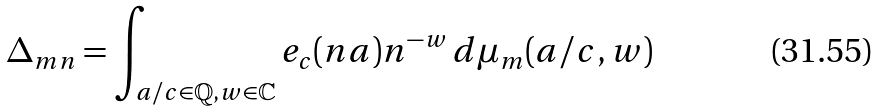Convert formula to latex. <formula><loc_0><loc_0><loc_500><loc_500>\Delta _ { m n } = \int _ { a / c \in \mathbb { Q } , w \in \mathbb { C } } e _ { c } ( n a ) n ^ { - w } \, d \mu _ { m } ( a / c , w )</formula> 